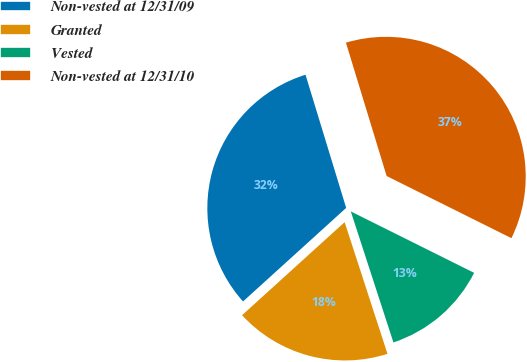Convert chart to OTSL. <chart><loc_0><loc_0><loc_500><loc_500><pie_chart><fcel>Non-vested at 12/31/09<fcel>Granted<fcel>Vested<fcel>Non-vested at 12/31/10<nl><fcel>32.01%<fcel>18.28%<fcel>12.64%<fcel>37.07%<nl></chart> 